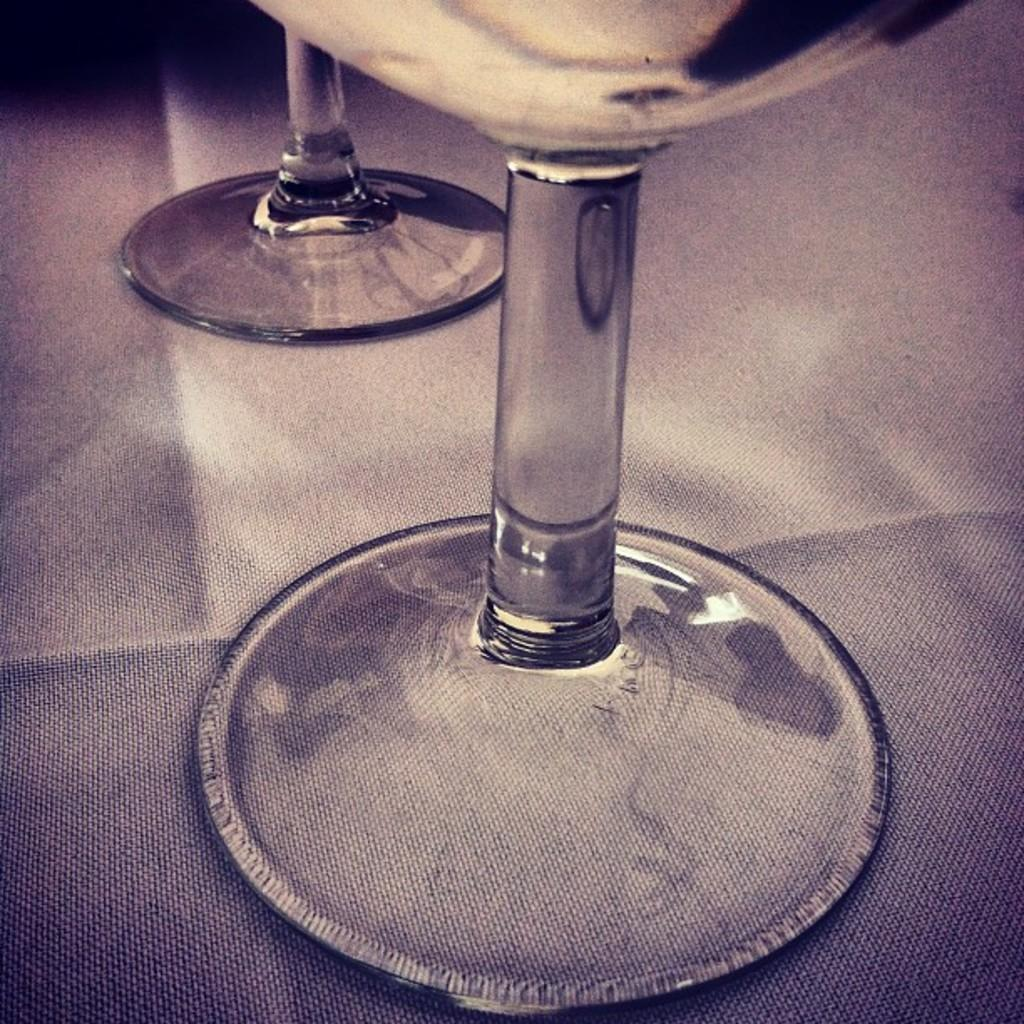How many wine glasses are visible in the image? There are two wine glasses in the image. Where are the wine glasses located? The wine glasses are on a surface. What is covering the top part of the image? There is a black colored shade on the top of the image. What type of oil is being used to create the idea in the image? There is no oil or idea present in the image; it only features two wine glasses on a surface with a black colored shade on top. 